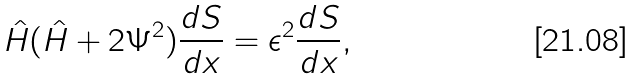<formula> <loc_0><loc_0><loc_500><loc_500>\hat { H } ( \hat { H } + 2 \Psi ^ { 2 } ) \frac { d S } { d x } = \epsilon ^ { 2 } \frac { d S } { d x } ,</formula> 